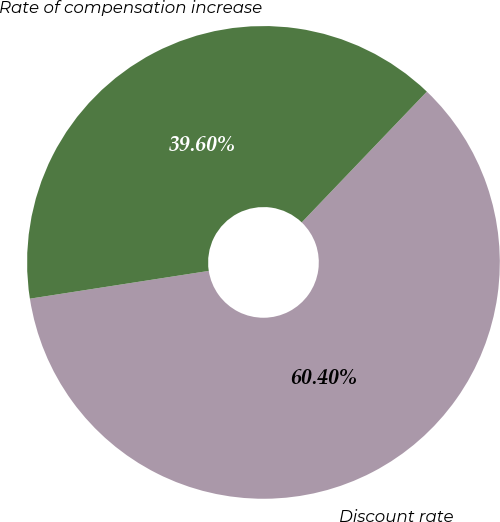Convert chart. <chart><loc_0><loc_0><loc_500><loc_500><pie_chart><fcel>Discount rate<fcel>Rate of compensation increase<nl><fcel>60.4%<fcel>39.6%<nl></chart> 